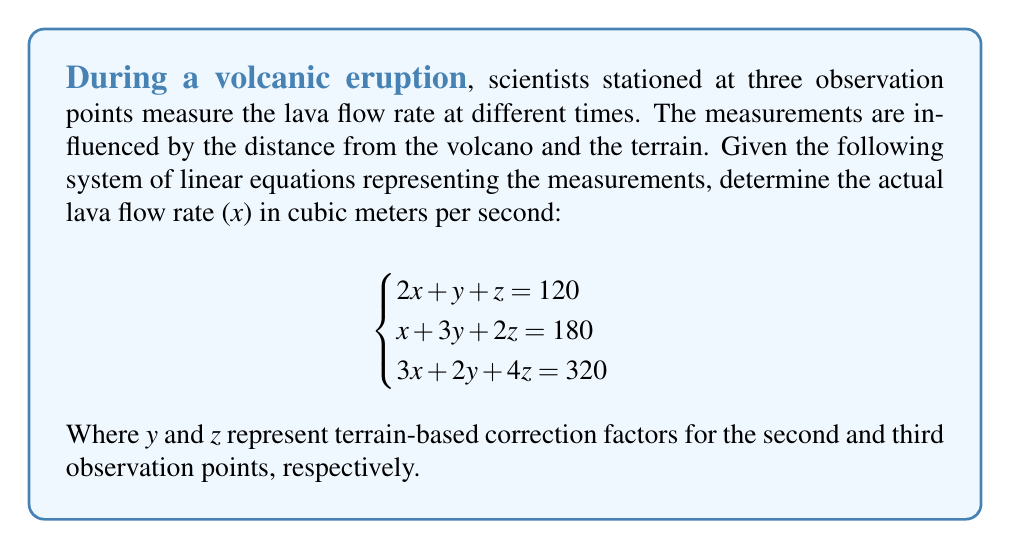Can you solve this math problem? To solve this system of linear equations, we'll use the Gaussian elimination method:

1. Write the augmented matrix:
   $$\begin{bmatrix}
   2 & 1 & 1 & 120 \\
   1 & 3 & 2 & 180 \\
   3 & 2 & 4 & 320
   \end{bmatrix}$$

2. Multiply the first row by -1/2 and add it to the second row:
   $$\begin{bmatrix}
   2 & 1 & 1 & 120 \\
   0 & 5/2 & 3/2 & 120 \\
   3 & 2 & 4 & 320
   \end{bmatrix}$$

3. Multiply the first row by -3/2 and add it to the third row:
   $$\begin{bmatrix}
   2 & 1 & 1 & 120 \\
   0 & 5/2 & 3/2 & 120 \\
   0 & 1/2 & 5/2 & 140
   \end{bmatrix}$$

4. Multiply the second row by -1/5 and add it to the third row:
   $$\begin{bmatrix}
   2 & 1 & 1 & 120 \\
   0 & 5/2 & 3/2 & 120 \\
   0 & 0 & 2 & 92
   \end{bmatrix}$$

5. Back-substitute to find z:
   $2z = 92$
   $z = 46$

6. Substitute z into the second row:
   $\frac{5}{2}y + \frac{3}{2}(46) = 120$
   $\frac{5}{2}y = 51$
   $y = \frac{51}{\frac{5}{2}} = \frac{102}{5} = 20.4$

7. Substitute y and z into the first row:
   $2x + 20.4 + 46 = 120$
   $2x = 53.6$
   $x = 26.8$

Therefore, the actual lava flow rate (x) is 26.8 cubic meters per second.
Answer: 26.8 m³/s 